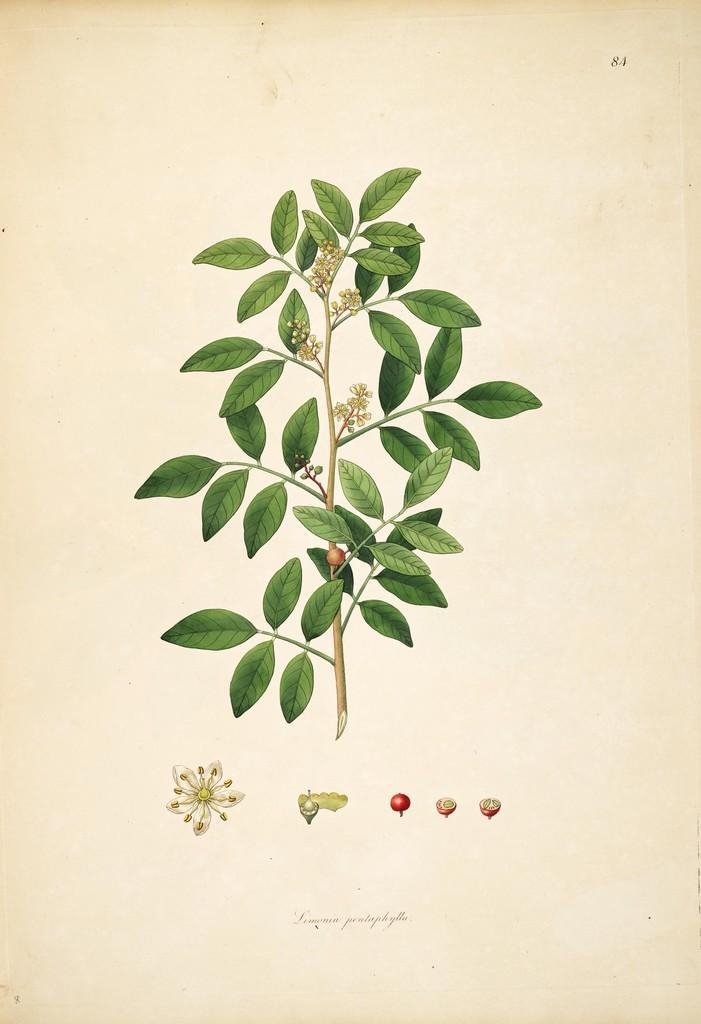Describe this image in one or two sentences. In the image there is a painting of a stem with leaves and branches. Also there are flowers and fruits. At the bottom of the image there are parts of flowers and fruits. 